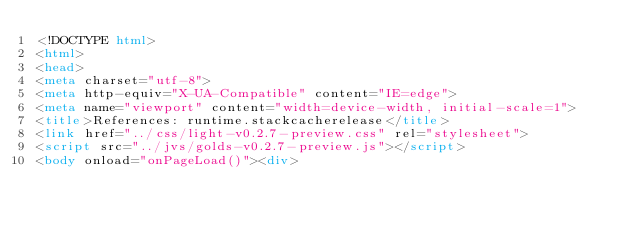Convert code to text. <code><loc_0><loc_0><loc_500><loc_500><_HTML_><!DOCTYPE html>
<html>
<head>
<meta charset="utf-8">
<meta http-equiv="X-UA-Compatible" content="IE=edge">
<meta name="viewport" content="width=device-width, initial-scale=1">
<title>References: runtime.stackcacherelease</title>
<link href="../css/light-v0.2.7-preview.css" rel="stylesheet">
<script src="../jvs/golds-v0.2.7-preview.js"></script>
<body onload="onPageLoad()"><div>
</code> 